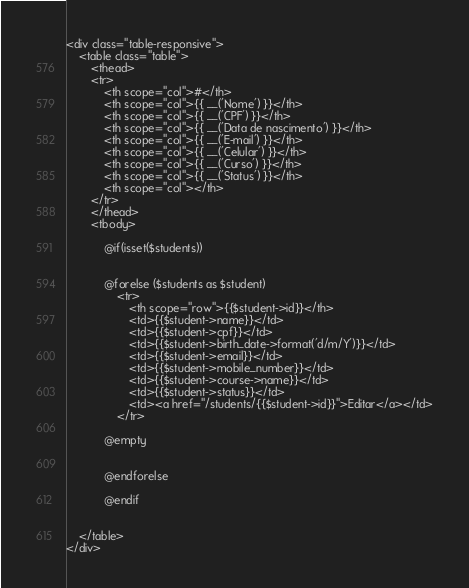<code> <loc_0><loc_0><loc_500><loc_500><_PHP_><div class="table-responsive">
    <table class="table">
        <thead>
        <tr>
            <th scope="col">#</th>
            <th scope="col">{{ __('Nome') }}</th>
            <th scope="col">{{ __('CPF') }}</th>
            <th scope="col">{{ __('Data de nascimento') }}</th>
            <th scope="col">{{ __('E-mail') }}</th>
            <th scope="col">{{ __('Celular') }}</th>
            <th scope="col">{{ __('Curso') }}</th>
            <th scope="col">{{ __('Status') }}</th>
            <th scope="col"></th>
        </tr>
        </thead>
        <tbody>

            @if(isset($students))
                

            @forelse ($students as $student)
                <tr>
                    <th scope="row">{{$student->id}}</th>
                    <td>{{$student->name}}</td>
                    <td>{{$student->cpf}}</td>
                    <td>{{$student->birth_date->format('d/m/Y')}}</td>
                    <td>{{$student->email}}</td>
                    <td>{{$student->mobile_number}}</td>
                    <td>{{$student->course->name}}</td>
                    <td>{{$student->status}}</td>
                    <td><a href="/students/{{$student->id}}">Editar</a></td>
                </tr>                                

            @empty
                

            @endforelse
            
            @endif
        
        
    </table>
</div></code> 